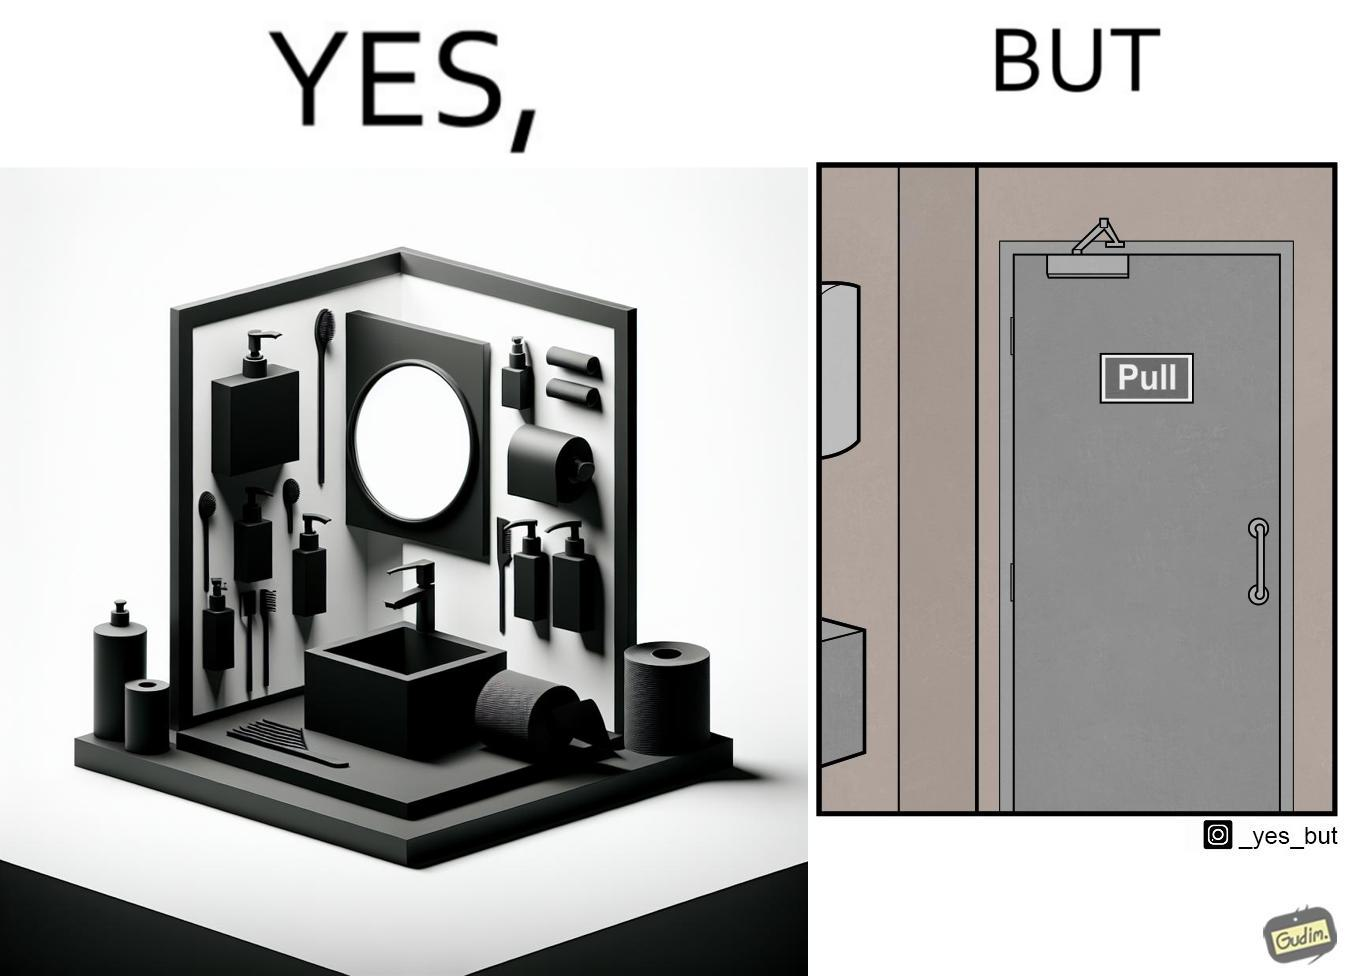What is shown in this image? The image is ironic, because in the first image in the bathroom there are so many things to clean hands around the basin but in the same bathroom people have to open the doors by hand which can easily spread the germs or bacteria even after times of hand cleaning as there is no way to open it without hands 